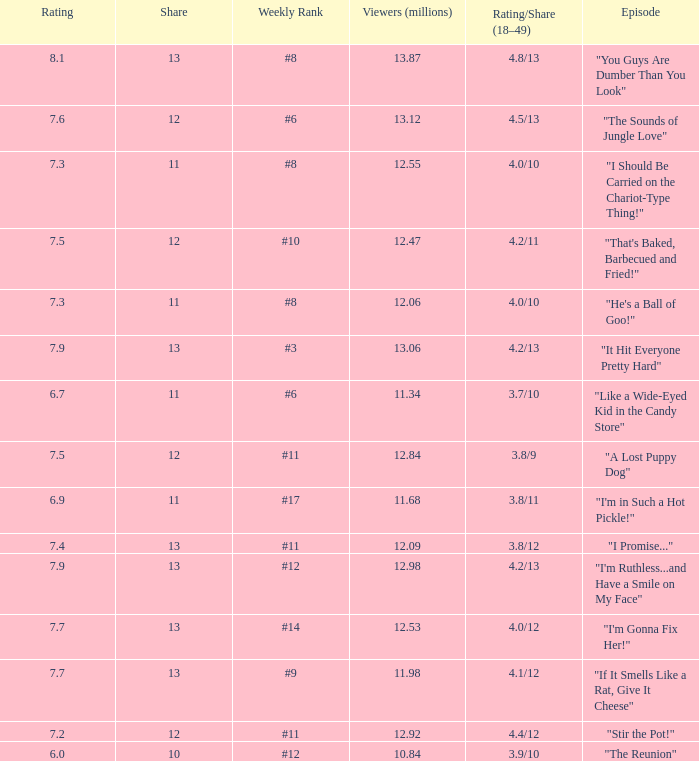What is the average rating for "a lost puppy dog"? 7.5. 